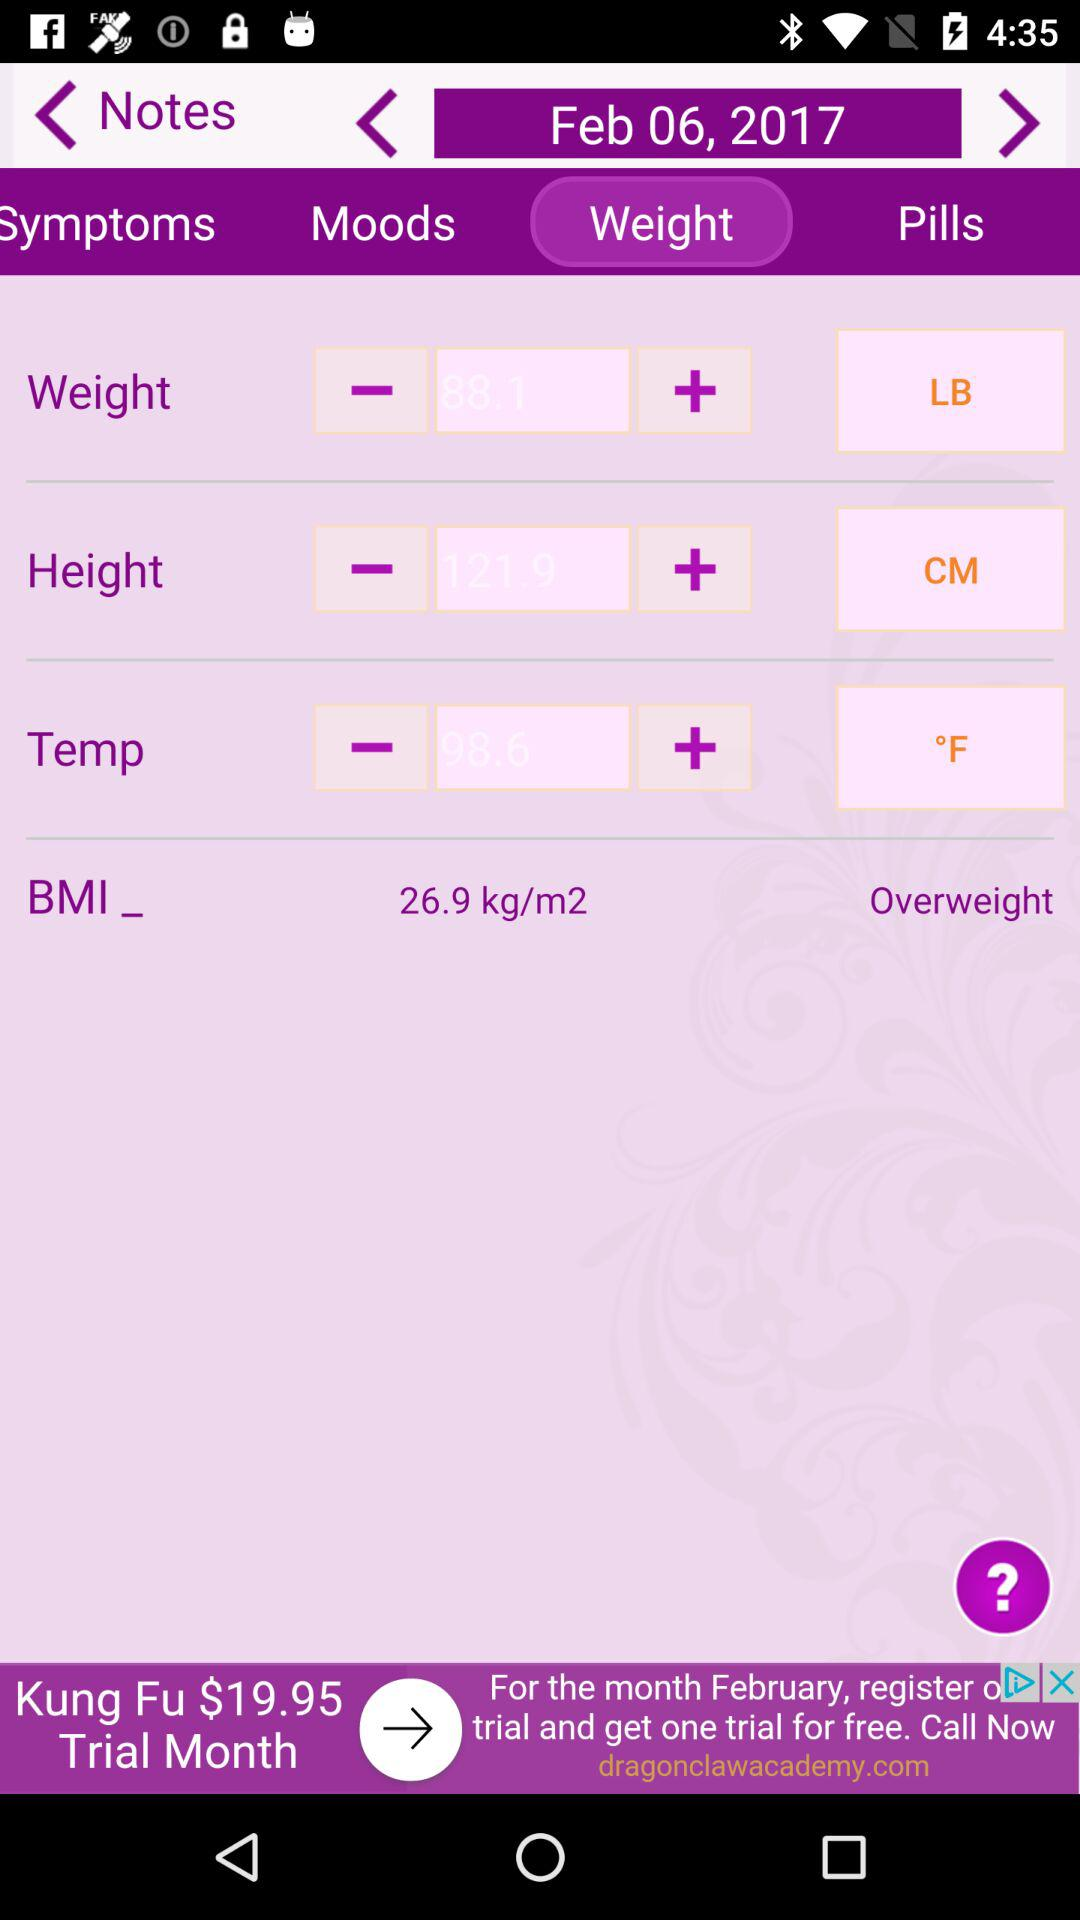What is the BMI of the person?
Answer the question using a single word or phrase. 26.9 kg/m2 